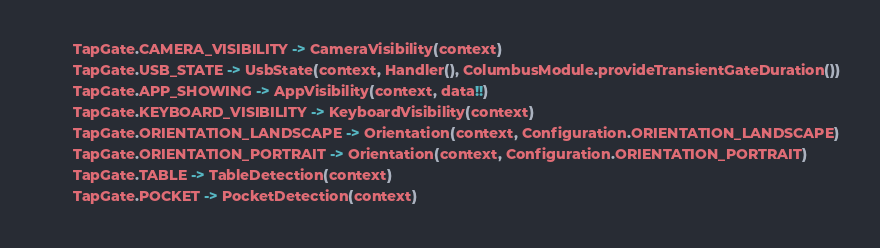<code> <loc_0><loc_0><loc_500><loc_500><_Kotlin_>        TapGate.CAMERA_VISIBILITY -> CameraVisibility(context)
        TapGate.USB_STATE -> UsbState(context, Handler(), ColumbusModule.provideTransientGateDuration())
        TapGate.APP_SHOWING -> AppVisibility(context, data!!)
        TapGate.KEYBOARD_VISIBILITY -> KeyboardVisibility(context)
        TapGate.ORIENTATION_LANDSCAPE -> Orientation(context, Configuration.ORIENTATION_LANDSCAPE)
        TapGate.ORIENTATION_PORTRAIT -> Orientation(context, Configuration.ORIENTATION_PORTRAIT)
        TapGate.TABLE -> TableDetection(context)
        TapGate.POCKET -> PocketDetection(context)</code> 